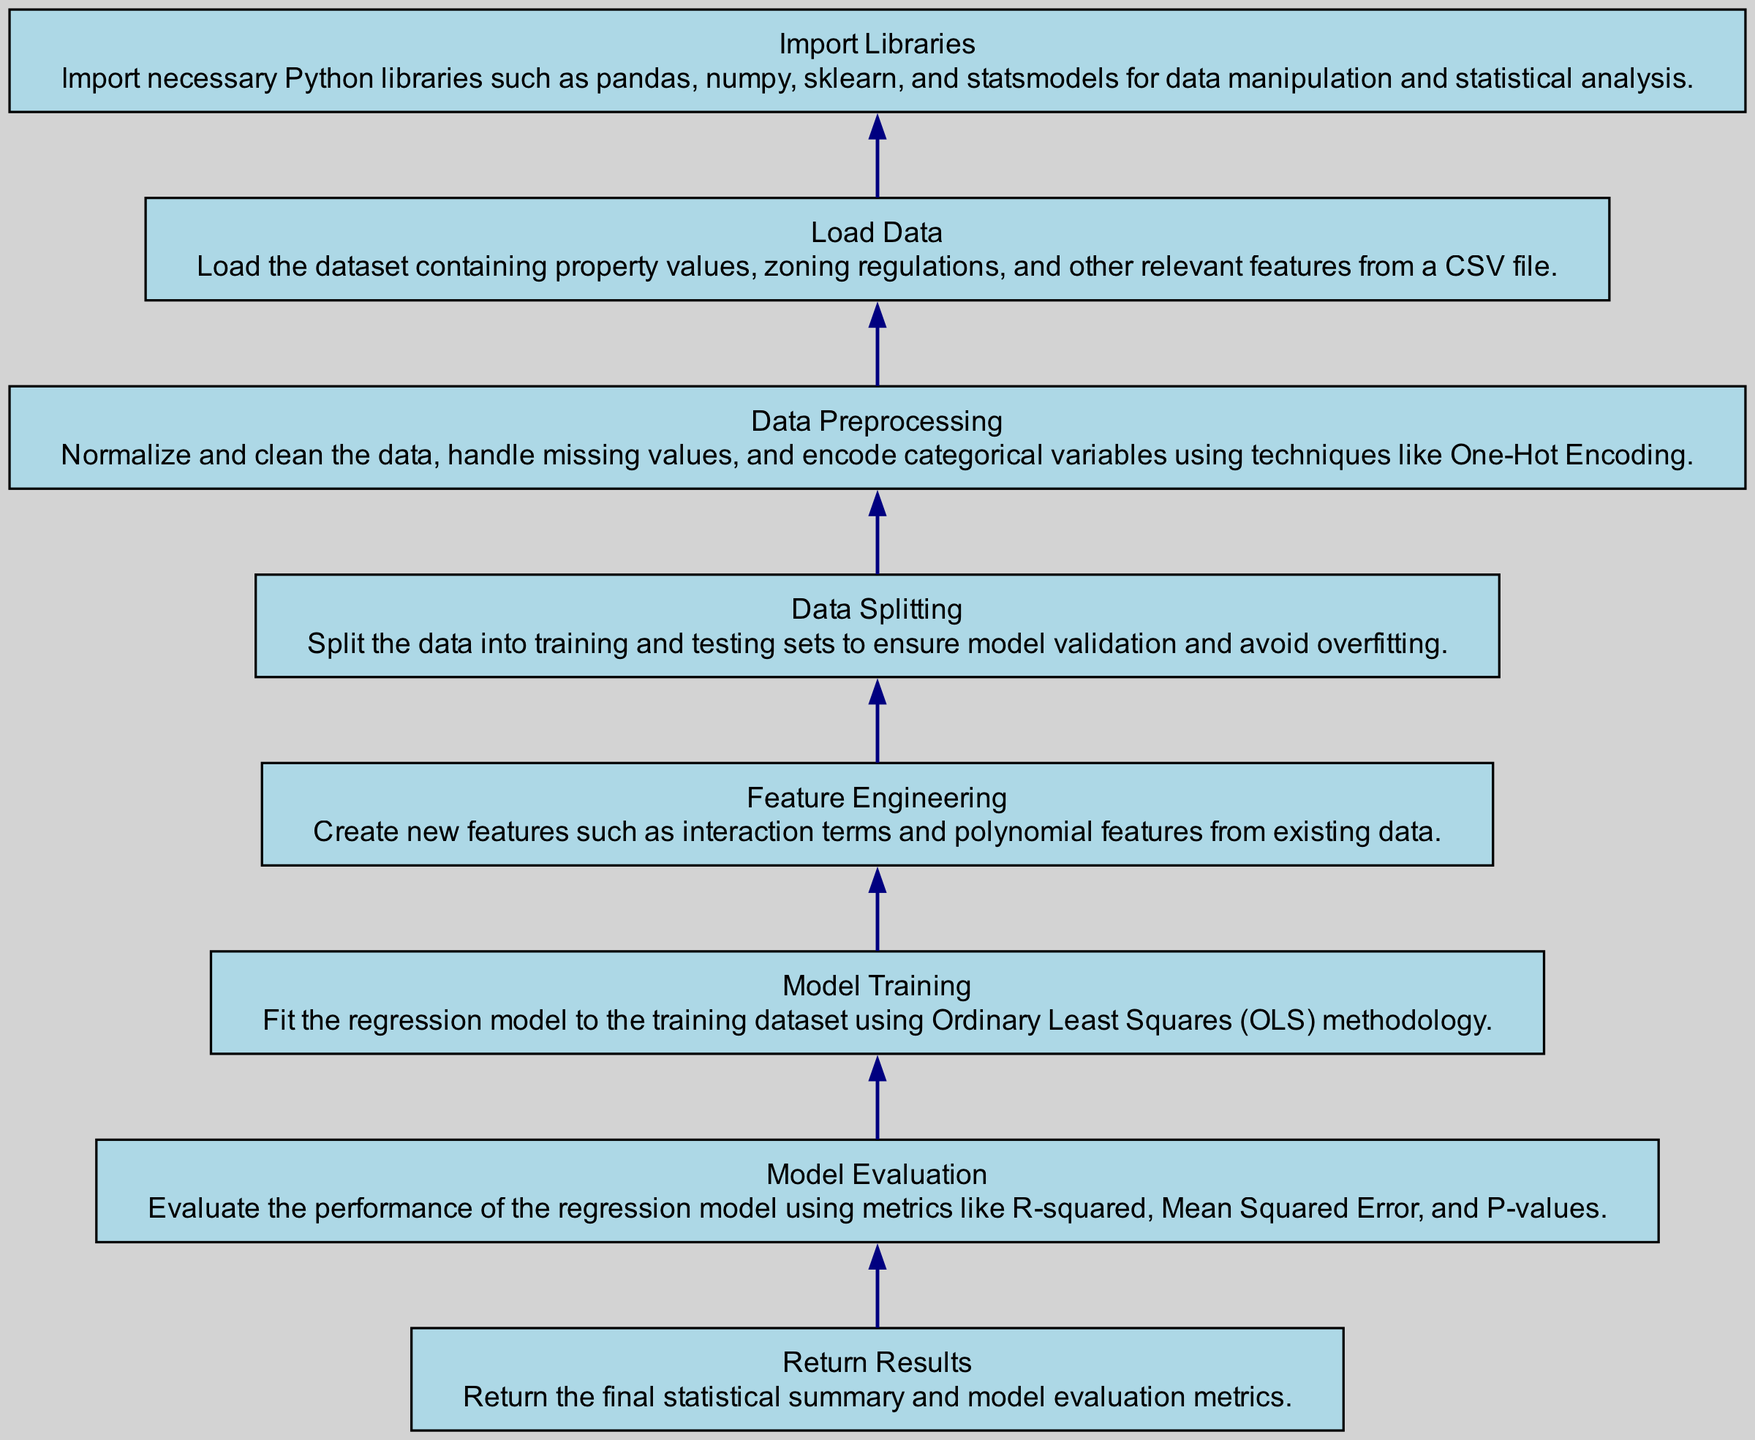What is the first step in the analysis process? The diagram indicates that the first step is "Import Libraries," necessary for data manipulation and statistical analysis.
Answer: Import Libraries How many nodes are there in the diagram? Counting all individual elements presented in the diagram, there are a total of 8 nodes.
Answer: 8 What are the last two steps in the modeling process? The last two steps before returning results are "Model Training" and "Model Evaluation," showing the progression of the analysis.
Answer: Model Training, Model Evaluation What step comes after data preprocessing? The flowchart shows that after "Data Preprocessing," the next step is "Data Splitting," where the dataset is divided for model validation.
Answer: Data Splitting What metrics are used in the model evaluation? The description under "Model Evaluation" specifies using R-squared, Mean Squared Error, and P-values to assess model performance.
Answer: R-squared, Mean Squared Error, P-values How does feature engineering influence the model training step? Feature engineering creates interaction and polynomial features that enhance the dataset, which is crucial for fitting a more accurate model during training.
Answer: Enhances model accuracy Which step ensures the model avoids overfitting? The "Data Splitting" step is designed to ensure the model avoids overfitting by validating its performance on separate test data.
Answer: Data Splitting What is the significance of the "Load Data" step? The "Load Data" step is important because it involves reading the relevant dataset from a CSV file to begin the entire analysis process.
Answer: Read dataset from CSV What type of analysis methodology is used in the "Model Training" step? The methodology indicated in the "Model Training" step is Ordinary Least Squares (OLS), which is a foundational technique for linear regression.
Answer: Ordinary Least Squares 